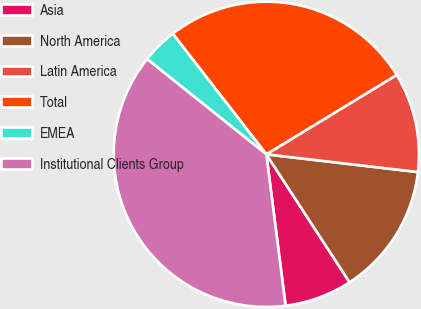Convert chart. <chart><loc_0><loc_0><loc_500><loc_500><pie_chart><fcel>Asia<fcel>North America<fcel>Latin America<fcel>Total<fcel>EMEA<fcel>Institutional Clients Group<nl><fcel>7.17%<fcel>13.96%<fcel>10.56%<fcel>26.8%<fcel>3.77%<fcel>37.74%<nl></chart> 